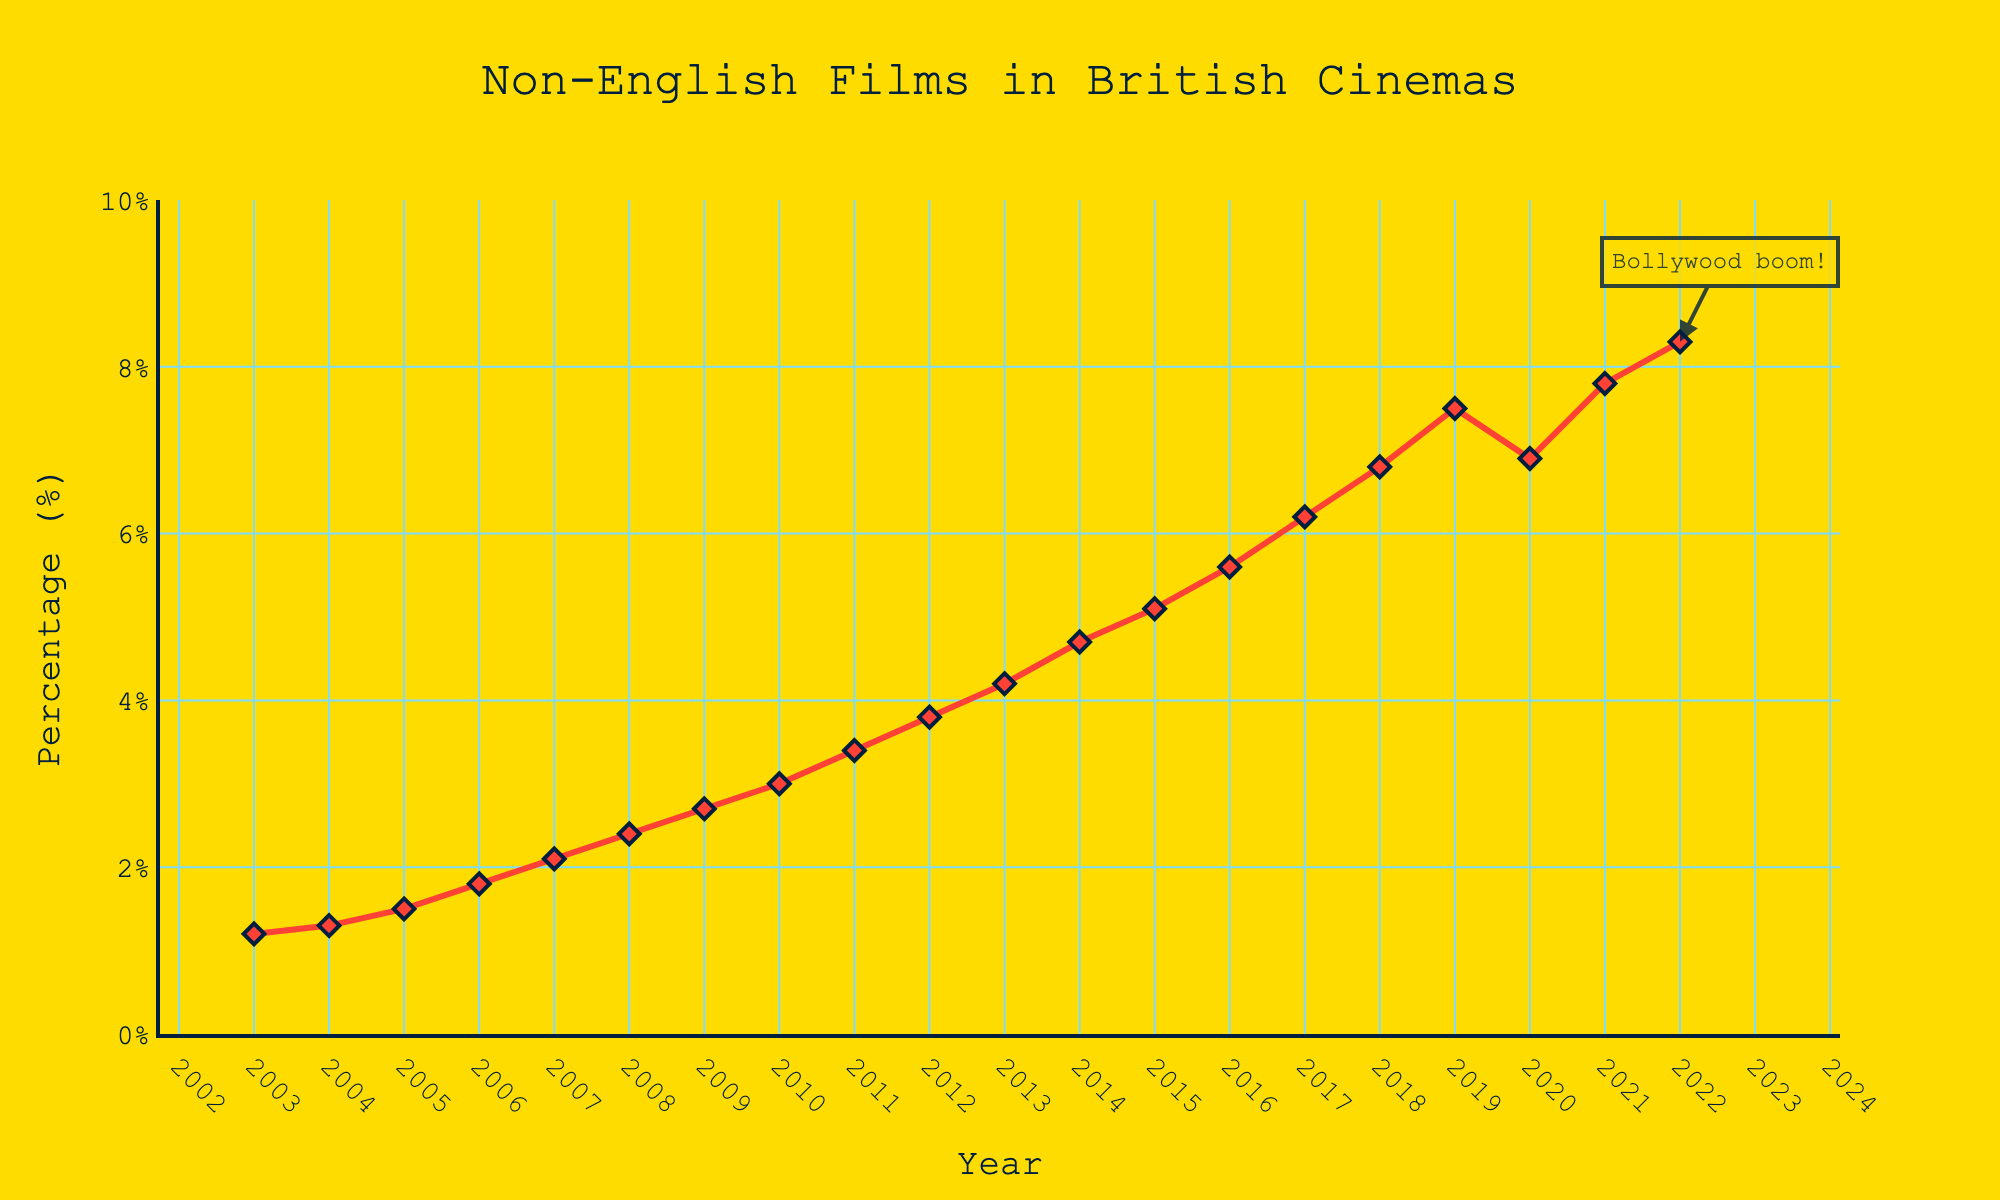What's the general trend in the frequency of non-English language film screenings in British cinemas over the last two decades? The graph shows a general upward trend in the percentage of non-English language film screenings in British cinemas, starting from 1.2% in 2003 and reaching 8.3% in 2022.
Answer: Upward trend Which year had the largest percentage drop in non-English screenings compared to the previous year? To find this, we look at the differences between each consecutive year's percentages. The largest drop occurs between 2019 (7.5%) and 2020 (6.9%), which is a decrease of 0.6%.
Answer: 2020 In which year did the percentage of non-English language screenings first exceed 5%? From the graph, the percentage first exceeds 5% in the year 2015.
Answer: 2015 How much did the percentage of non-English films increase from 2003 to 2022? The formula to calculate this is the percentage in 2022 minus the percentage in 2003: 8.3% - 1.2% = 7.1%.
Answer: 7.1% When comparing 2011 and 2021, which year had a greater percentage of non-English language screenings, and by how much? The percentage in 2021 (7.8%) is greater than the percentage in 2011 (3.4%). The difference is 7.8% - 3.4% = 4.4%.
Answer: 2021 by 4.4% What visual attribute indicates the recent annotation on the chart? The annotation is highlighted with an arrow pointing to the data point in 2022, labelled "Bollywood boom!", and has a surrounding box.
Answer: Arrow and annotation box What was the average annual increase in the percentage of non-English films from 2003 to 2022? To find the average annual increase, we use the total increase (8.3% - 1.2% = 7.1%) divided by the total number of years (2022 - 2003 = 19 years). Thus, the average annual increase is 7.1% / 19 ≈ 0.37%.
Answer: 0.37% Identify the trend between 2019 and 2021, and explain how 2020 fits into this trend. From 2019 to 2021, the overall trend is increasing except for a dip in 2020. Specifically, there's a decrease from 7.5% in 2019 to 6.9% in 2020 followed by an increase to 7.8% in 2021.
Answer: Decreasing in 2020, then increasing in 2021 What is the percentage change in non-English language screenings from 2018 to 2019? The percentage in 2018 was 6.8%, and in 2019 it was 7.5%. The percentage change is calculated as (7.5% - 6.8%) / 6.8% × 100 ≈ 10.3%.
Answer: 10.3% Is there any year where the percentage of non-English films was the same as in the previous year? By examining the graph, we see that no years have the exact same percentage value for non-English films.
Answer: No 